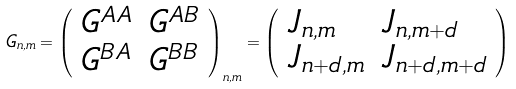<formula> <loc_0><loc_0><loc_500><loc_500>G _ { n , m } = \left ( \begin{array} { l l } G ^ { A A } & G ^ { A B } \\ G ^ { B A } & G ^ { B B } \end{array} \right ) _ { n , m } = \left ( \begin{array} { l l } J _ { n , m } & J _ { n , m + d } \\ J _ { n + d , m } & J _ { n + d , m + d } \end{array} \right )</formula> 